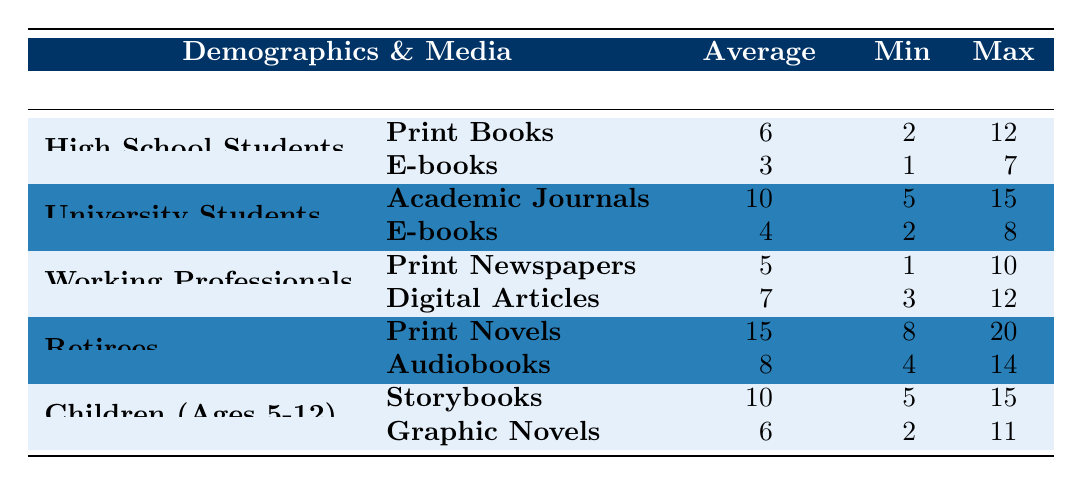What is the average time spent on reading Print Books by High School Students? According to the table, the average time spent on reading Print Books by High School Students is listed directly as 6 hours per week.
Answer: 6 hours Which demographic spends the most time reading audiobooks? The table indicates that Retirees spend 8 hours per week reading audiobooks, which is higher than the other demographics listed.
Answer: Retirees What is the maximum time spent on reading Storybooks by Children (Ages 5-12)? The maximum time listed for reading Storybooks by Children (Ages 5-12) is 15 hours, as specified in the table.
Answer: 15 hours How many hours, on average, do University Students spend reading E-books? The table shows that University Students spend an average of 4 hours per week reading E-books.
Answer: 4 hours What is the total average time spent on reading by Working Professionals across both media? For Working Professionals, the average time for Print Newspapers is 5 hours and for Digital Articles is 7 hours. Total average = 5 + 7 = 12 hours.
Answer: 12 hours Is the average time spent reading Print Novels by Retirees greater than that of High School Students reading Print Books? The average time for Retirees reading Print Novels is 15 hours, while for High School Students reading Print Books it is 6 hours. Since 15 is greater than 6, the answer is yes.
Answer: Yes What is the minimum time spent on reading E-books across all demographics? The minimum time spent reading E-books is 1 hour, noted in the table for High School Students.
Answer: 1 hour Calculate the difference between the maximum time spent on Print Novels by Retirees and the average time spent on Digital Articles by Working Professionals. The maximum time for Retirees reading Print Novels is 20 hours, while the average time for Working Professionals reading Digital Articles is 7 hours. The difference is 20 - 7 = 13 hours.
Answer: 13 hours Which demographic spends the least time reading E-books? In the table, High School Students spend 3 hours on E-books and University Students spend 4 hours. Therefore, High School Students spend the least time reading E-books.
Answer: High School Students What demographic has the highest average time spent reading, and what is the average time? The table shows that Retirees spend 15 hours on Print Novels, which is the highest average time spent on reading compared to other demographics.
Answer: Retirees, 15 hours 